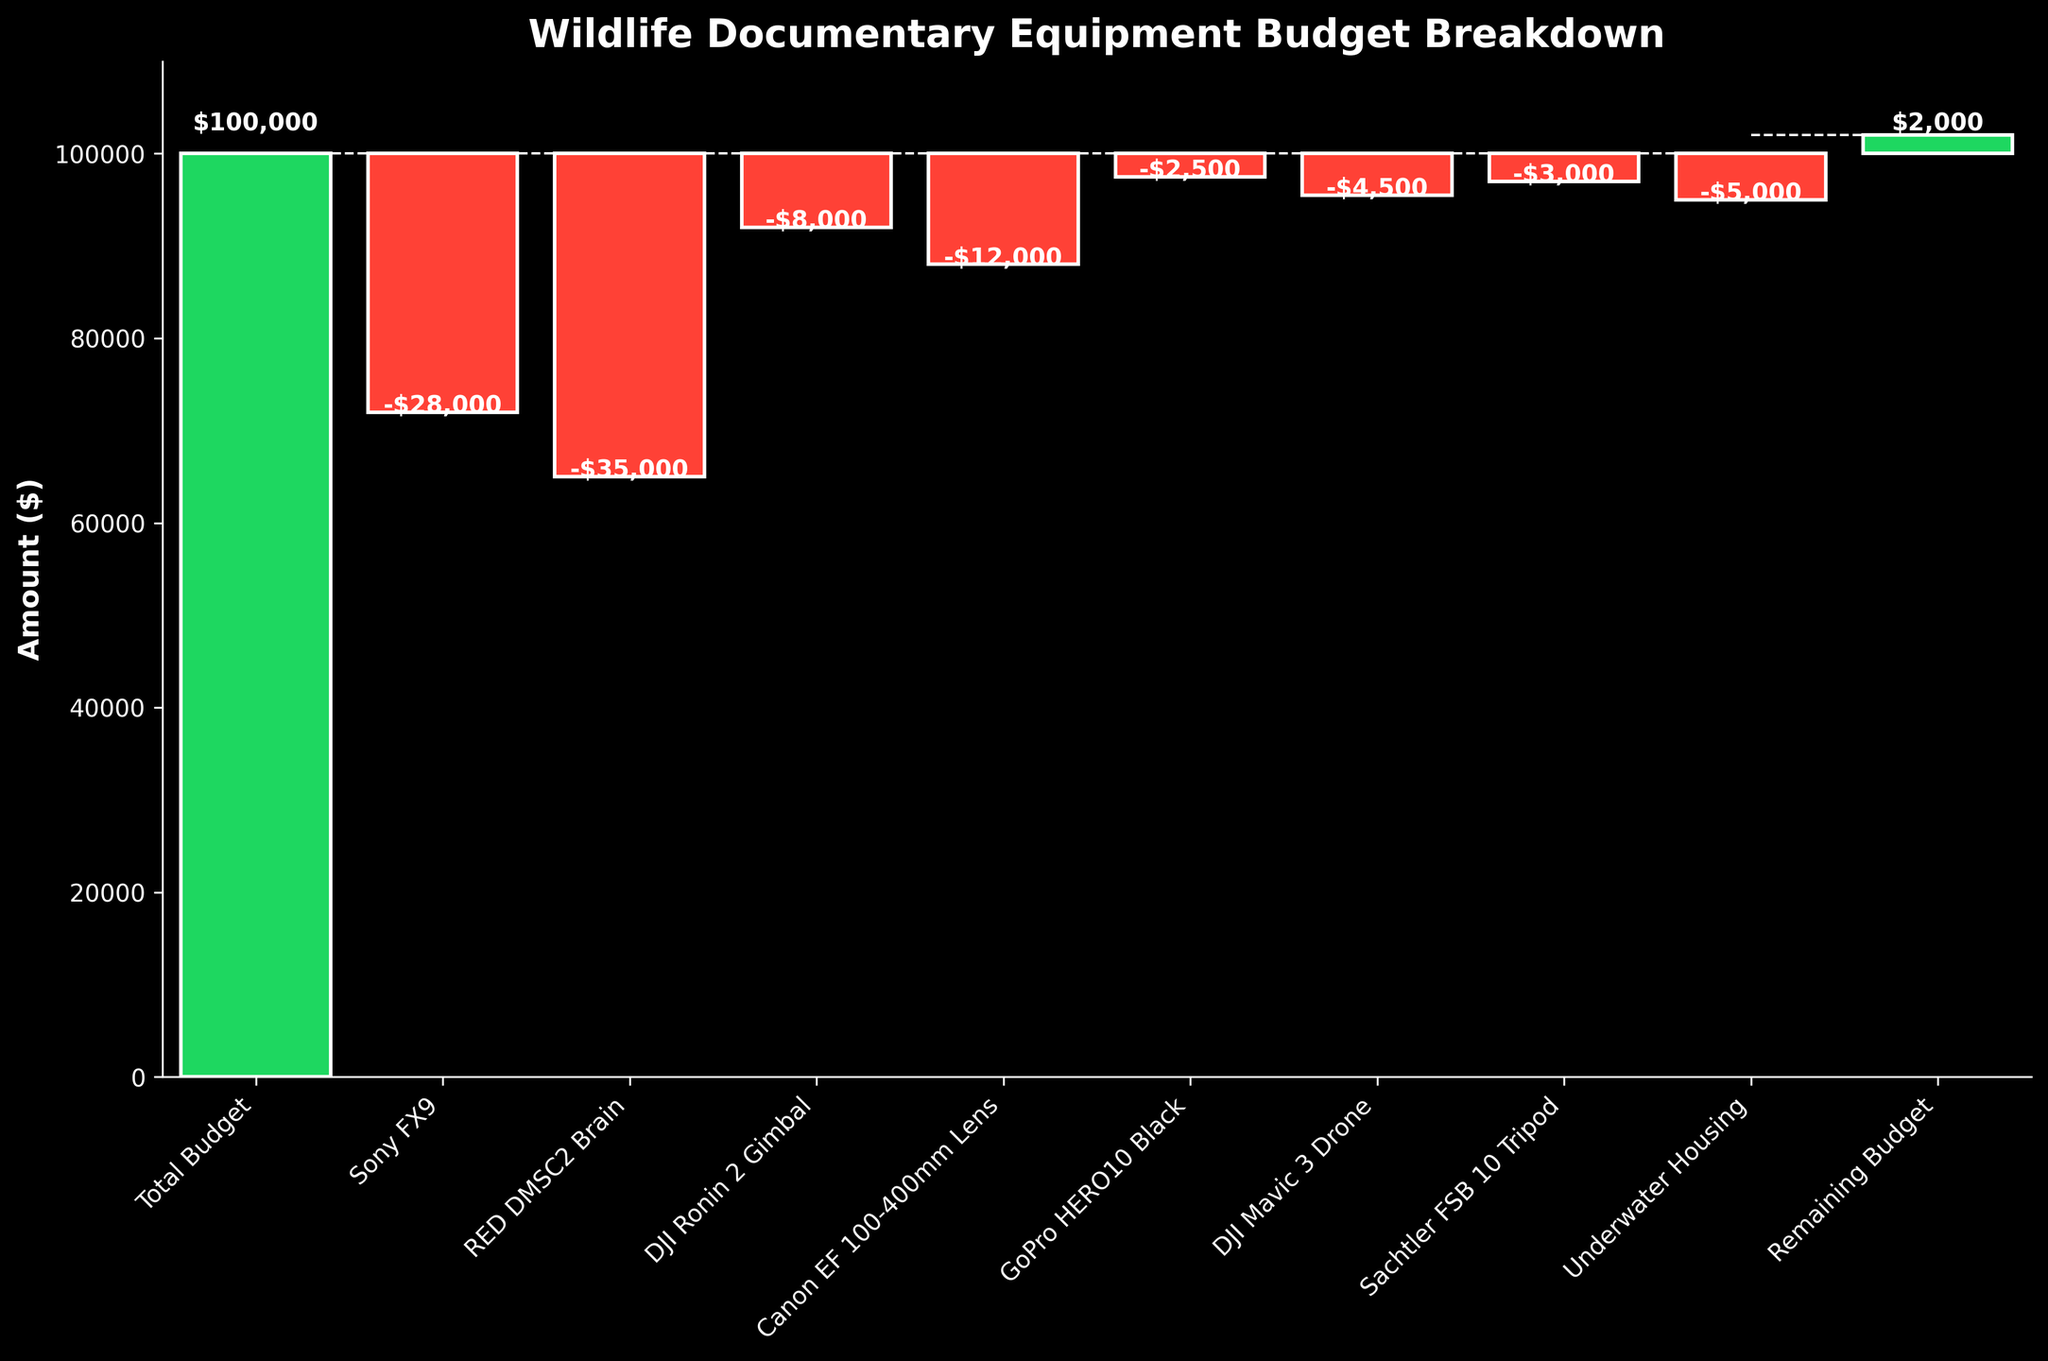What is the total initial budget allocated for wildlife documentary equipment? The title of the figure indicates it is a budget breakdown for equipment. The first bar labeled 'Total Budget' shows the starting amount.
Answer: $100,000 What is the amount spent on the RED DMSC2 Brain camera? Looking at the bar labeled 'RED DMSC2 Brain', it shows a descending bar indicating an expenditure with the amount written in white text at the top.
Answer: $35,000 What is the remaining budget after all equipment purchases? The last bar labeled 'Remaining Budget' shows the final remaining amount.
Answer: $2,000 How much more expensive is the Sony FX9 compared to the DJI Mavic 3 Drone? Identify the values for both items and calculate the difference; amount for Sony FX9 is $28,000 and DJI Mavic 3 Drone is $4,500. Subtract the two.
Answer: $23,500 Which equipment had the lowest expenditure? Compare all downward bars to identify the smallest expenditure; here, the GoPro HERO10 Black with the labeled amount.
Answer: $2,500 What is the total expenditure on all cameras? Total expenditure involves summing up all camera-related values: Sony FX9 ($28,000), RED DMSC2 Brain ($35,000), DJI Ronin 2 Gimbal ($8,000), and GoPro HERO10 Black ($2,500).
Answer: $73,500 How many different equipment categories are included in the budget allocation? Count the distinct labels on the x-axis; categories include Total Budget, each equipment type, and Remaining Budget.
Answer: 10 By how much does the total camera expenditure exceed the remaining budget? Initially find the total camera expenditure ($73,500), then subtract the remaining budget amount ($2,000) from it.
Answer: $71,500 Which piece of equipment is the second most expensive? Rank all expenditures and identify the second highest, which is the Sony FX9 at $28,000 after the RED DMSC2 Brain.
Answer: Sony FX9 What percentage of the total budget was spent on the Canon EF 100-400mm Lens? Calculate the percentage by dividing the lens cost ($12,000) by the total budget ($100,000) and multiplying by 100.
Answer: 12% 